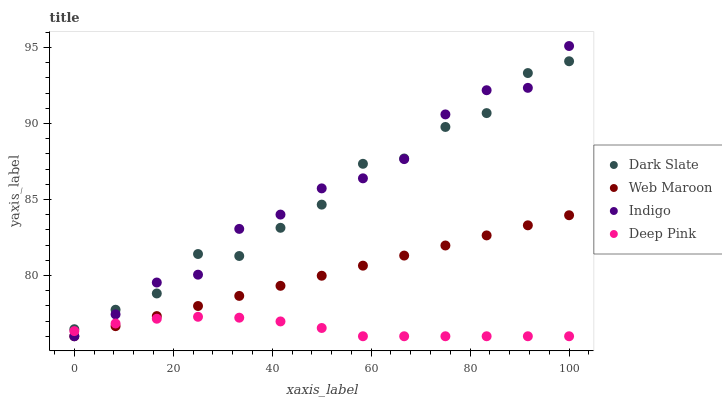Does Deep Pink have the minimum area under the curve?
Answer yes or no. Yes. Does Indigo have the maximum area under the curve?
Answer yes or no. Yes. Does Web Maroon have the minimum area under the curve?
Answer yes or no. No. Does Web Maroon have the maximum area under the curve?
Answer yes or no. No. Is Web Maroon the smoothest?
Answer yes or no. Yes. Is Dark Slate the roughest?
Answer yes or no. Yes. Is Deep Pink the smoothest?
Answer yes or no. No. Is Deep Pink the roughest?
Answer yes or no. No. Does Deep Pink have the lowest value?
Answer yes or no. Yes. Does Indigo have the highest value?
Answer yes or no. Yes. Does Web Maroon have the highest value?
Answer yes or no. No. Is Deep Pink less than Dark Slate?
Answer yes or no. Yes. Is Dark Slate greater than Web Maroon?
Answer yes or no. Yes. Does Deep Pink intersect Indigo?
Answer yes or no. Yes. Is Deep Pink less than Indigo?
Answer yes or no. No. Is Deep Pink greater than Indigo?
Answer yes or no. No. Does Deep Pink intersect Dark Slate?
Answer yes or no. No. 